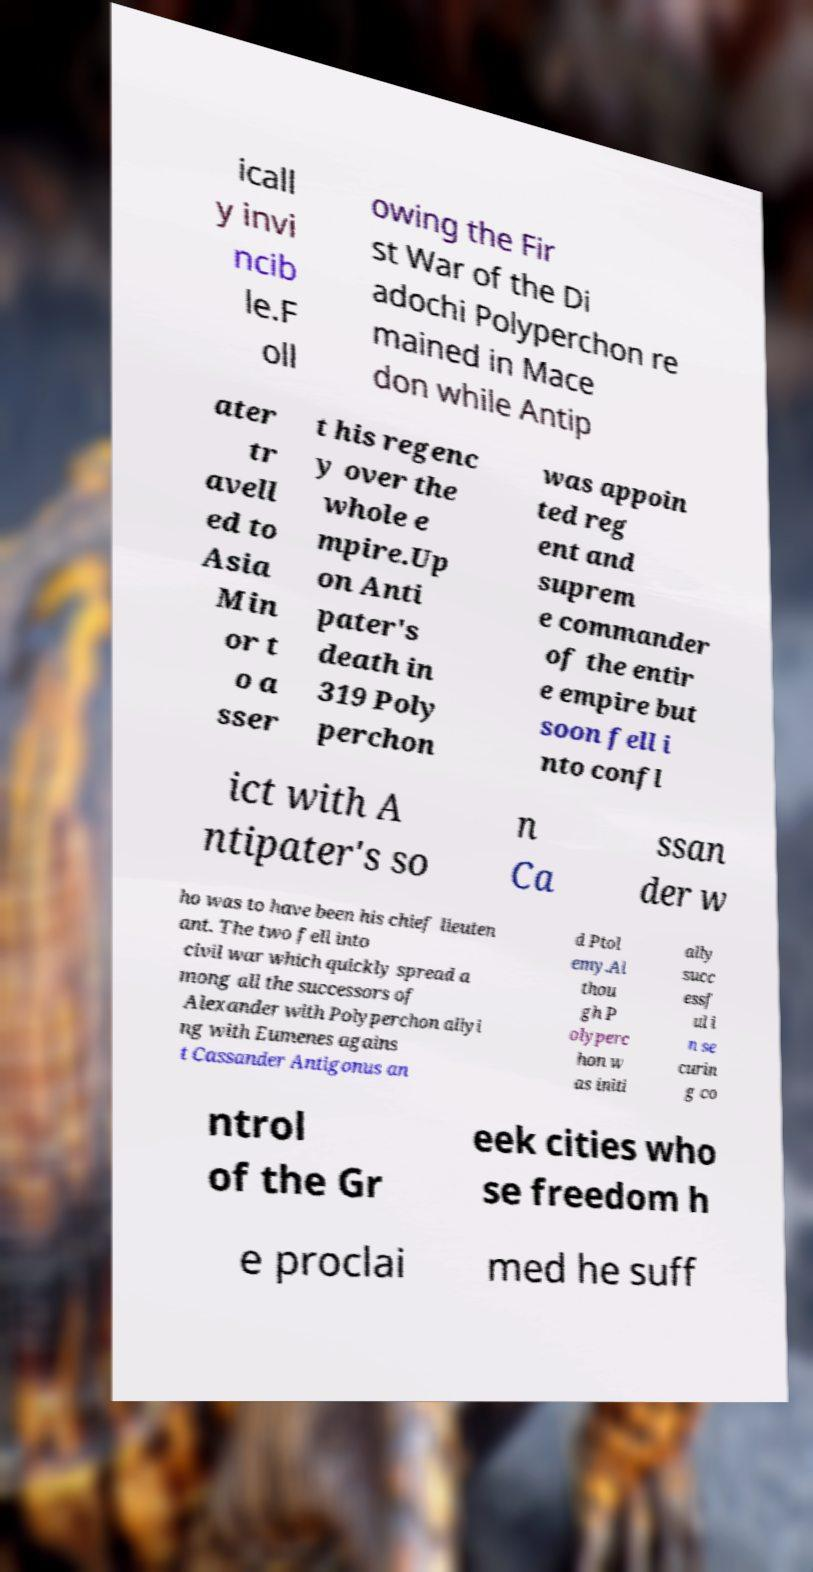Please identify and transcribe the text found in this image. icall y invi ncib le.F oll owing the Fir st War of the Di adochi Polyperchon re mained in Mace don while Antip ater tr avell ed to Asia Min or t o a sser t his regenc y over the whole e mpire.Up on Anti pater's death in 319 Poly perchon was appoin ted reg ent and suprem e commander of the entir e empire but soon fell i nto confl ict with A ntipater's so n Ca ssan der w ho was to have been his chief lieuten ant. The two fell into civil war which quickly spread a mong all the successors of Alexander with Polyperchon allyi ng with Eumenes agains t Cassander Antigonus an d Ptol emy.Al thou gh P olyperc hon w as initi ally succ essf ul i n se curin g co ntrol of the Gr eek cities who se freedom h e proclai med he suff 